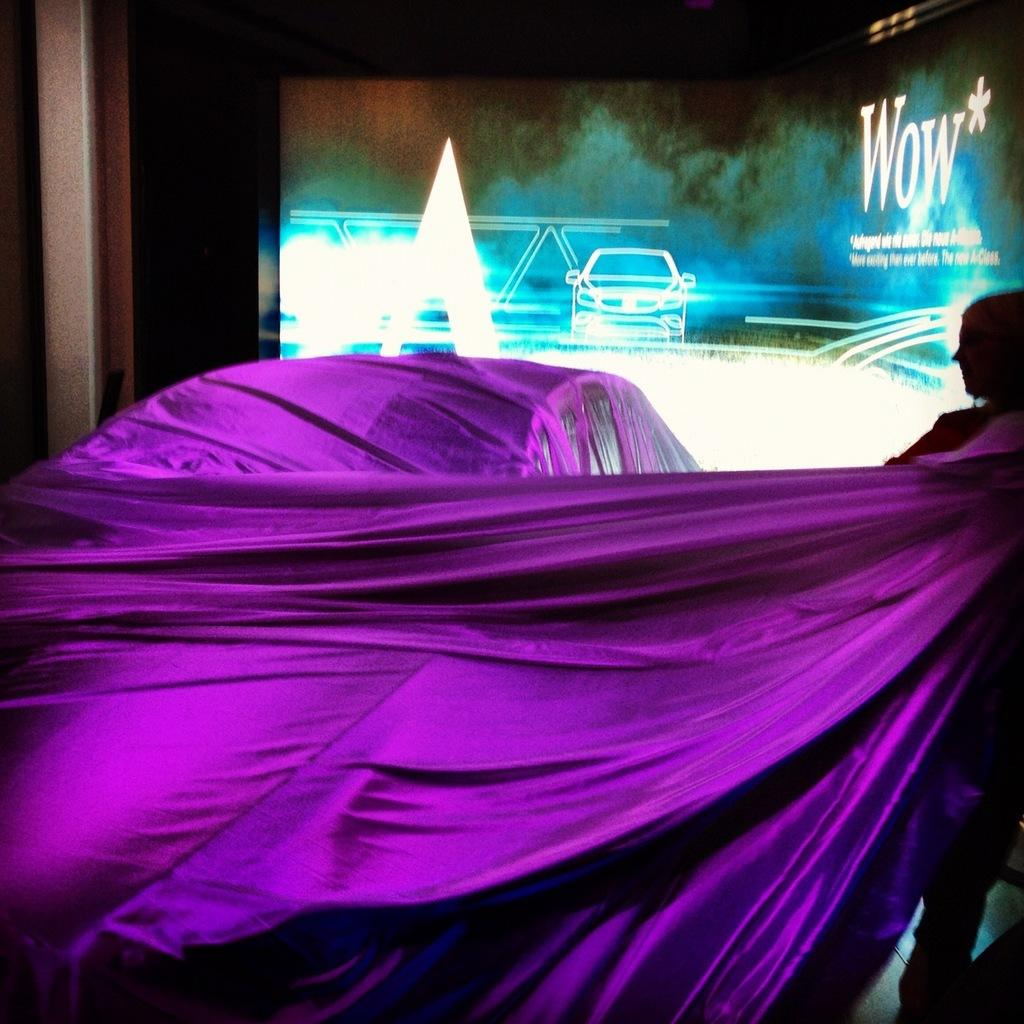What is the man in the image doing? The man is standing and pulling a cloth on a car. What can be seen in the background of the image? There is a screen with an advertisement in the background. What is the advertisement promoting? The advertisement is for the car. What feature of the car is visible in the image? The car has lights. Can you see any harbor or boats in the image? No, there is no harbor or boats present in the image. Is there a drum set visible in the image? No, there is no drum set present in the image. 